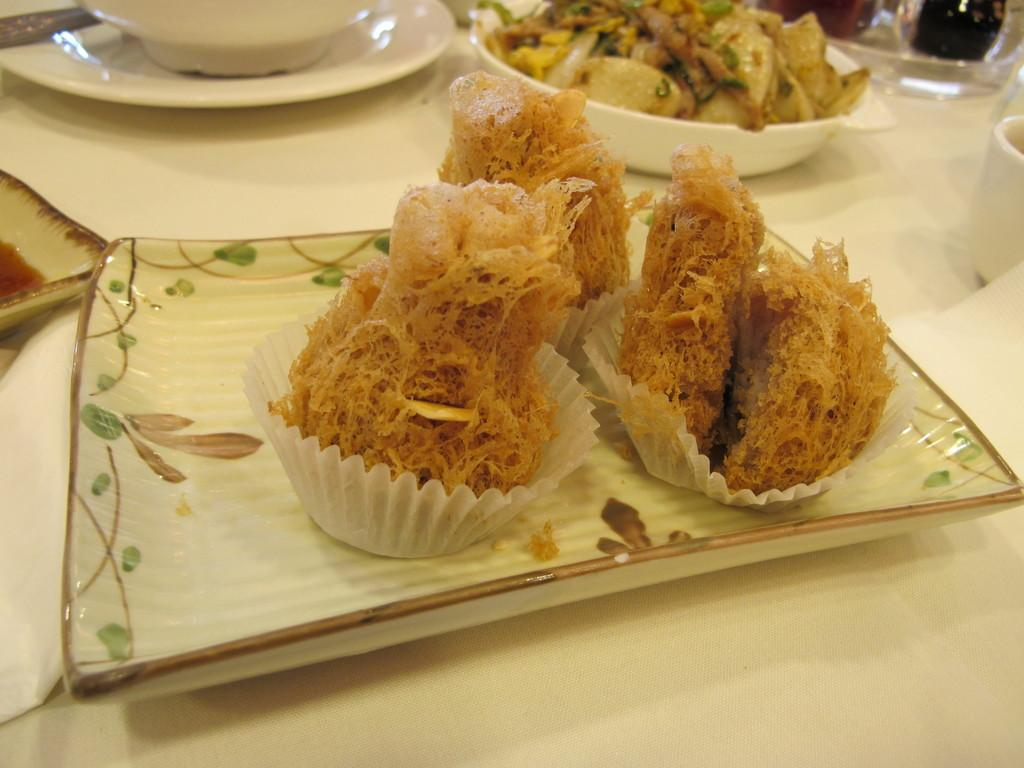What is on the plate that is visible in the image? There is a plate with food in the image. What else can be seen in the image besides the plate with food? There is a bowl with food at the top of the image and another plate in the top left of the image. What type of yarn is being used to hold the plate in the image? There is no yarn present in the image; the plate is resting on a surface. 